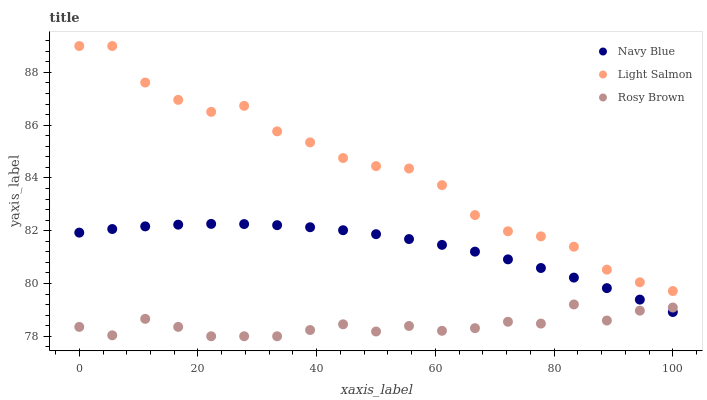Does Rosy Brown have the minimum area under the curve?
Answer yes or no. Yes. Does Light Salmon have the maximum area under the curve?
Answer yes or no. Yes. Does Light Salmon have the minimum area under the curve?
Answer yes or no. No. Does Rosy Brown have the maximum area under the curve?
Answer yes or no. No. Is Navy Blue the smoothest?
Answer yes or no. Yes. Is Light Salmon the roughest?
Answer yes or no. Yes. Is Rosy Brown the smoothest?
Answer yes or no. No. Is Rosy Brown the roughest?
Answer yes or no. No. Does Rosy Brown have the lowest value?
Answer yes or no. Yes. Does Light Salmon have the lowest value?
Answer yes or no. No. Does Light Salmon have the highest value?
Answer yes or no. Yes. Does Rosy Brown have the highest value?
Answer yes or no. No. Is Rosy Brown less than Light Salmon?
Answer yes or no. Yes. Is Light Salmon greater than Rosy Brown?
Answer yes or no. Yes. Does Rosy Brown intersect Navy Blue?
Answer yes or no. Yes. Is Rosy Brown less than Navy Blue?
Answer yes or no. No. Is Rosy Brown greater than Navy Blue?
Answer yes or no. No. Does Rosy Brown intersect Light Salmon?
Answer yes or no. No. 